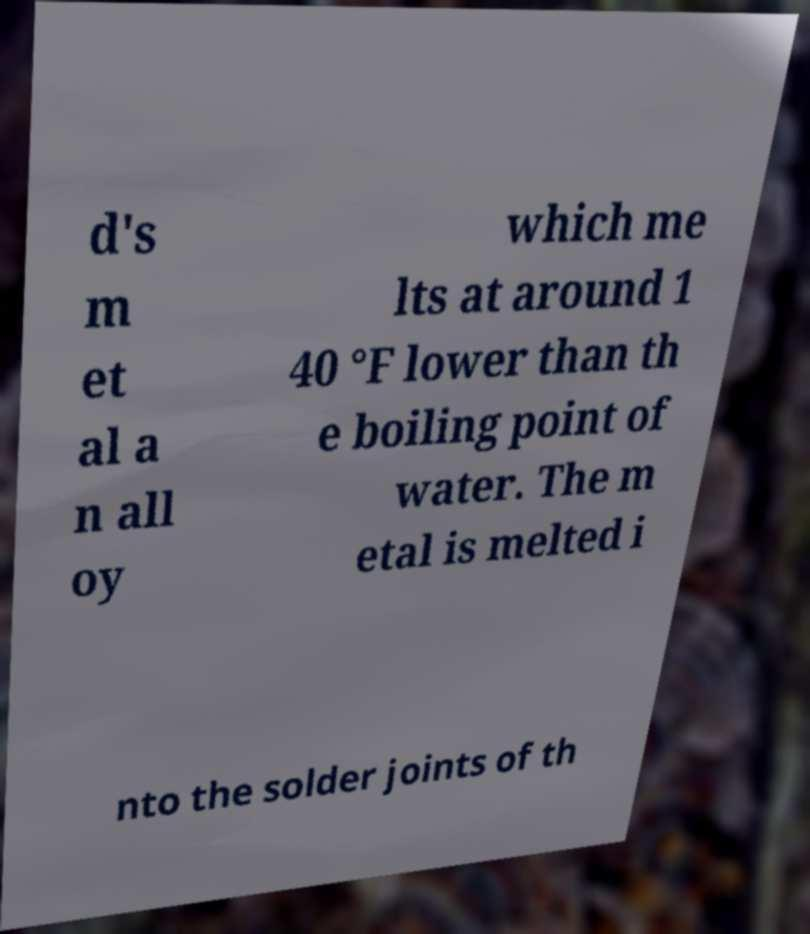Please identify and transcribe the text found in this image. d's m et al a n all oy which me lts at around 1 40 °F lower than th e boiling point of water. The m etal is melted i nto the solder joints of th 